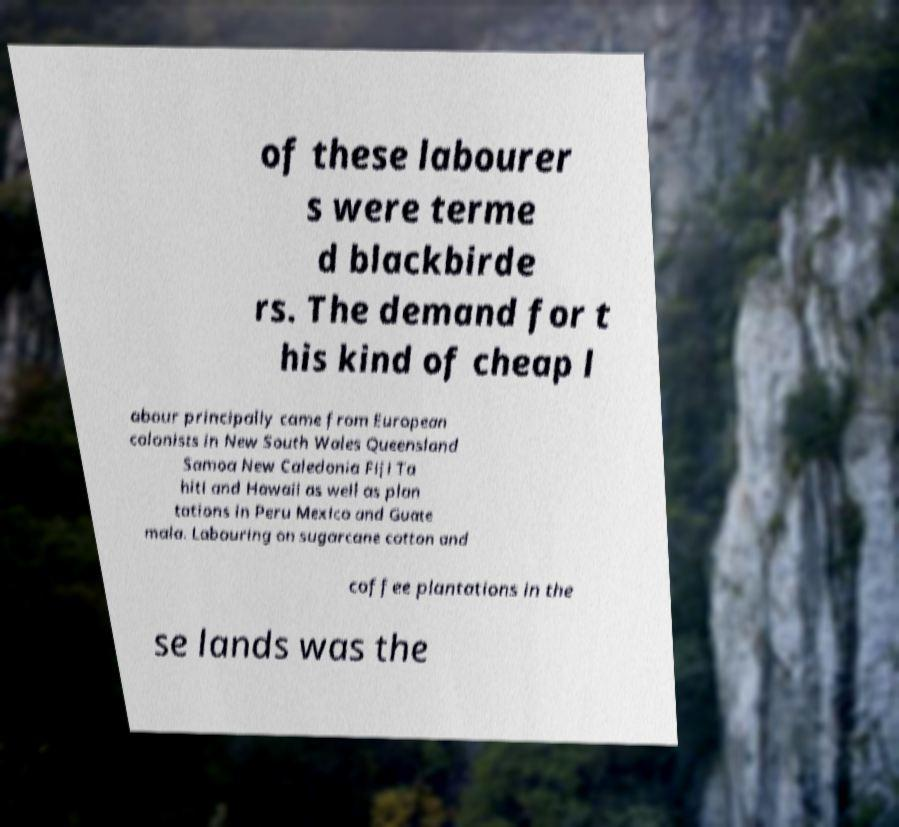Could you assist in decoding the text presented in this image and type it out clearly? of these labourer s were terme d blackbirde rs. The demand for t his kind of cheap l abour principally came from European colonists in New South Wales Queensland Samoa New Caledonia Fiji Ta hiti and Hawaii as well as plan tations in Peru Mexico and Guate mala. Labouring on sugarcane cotton and coffee plantations in the se lands was the 